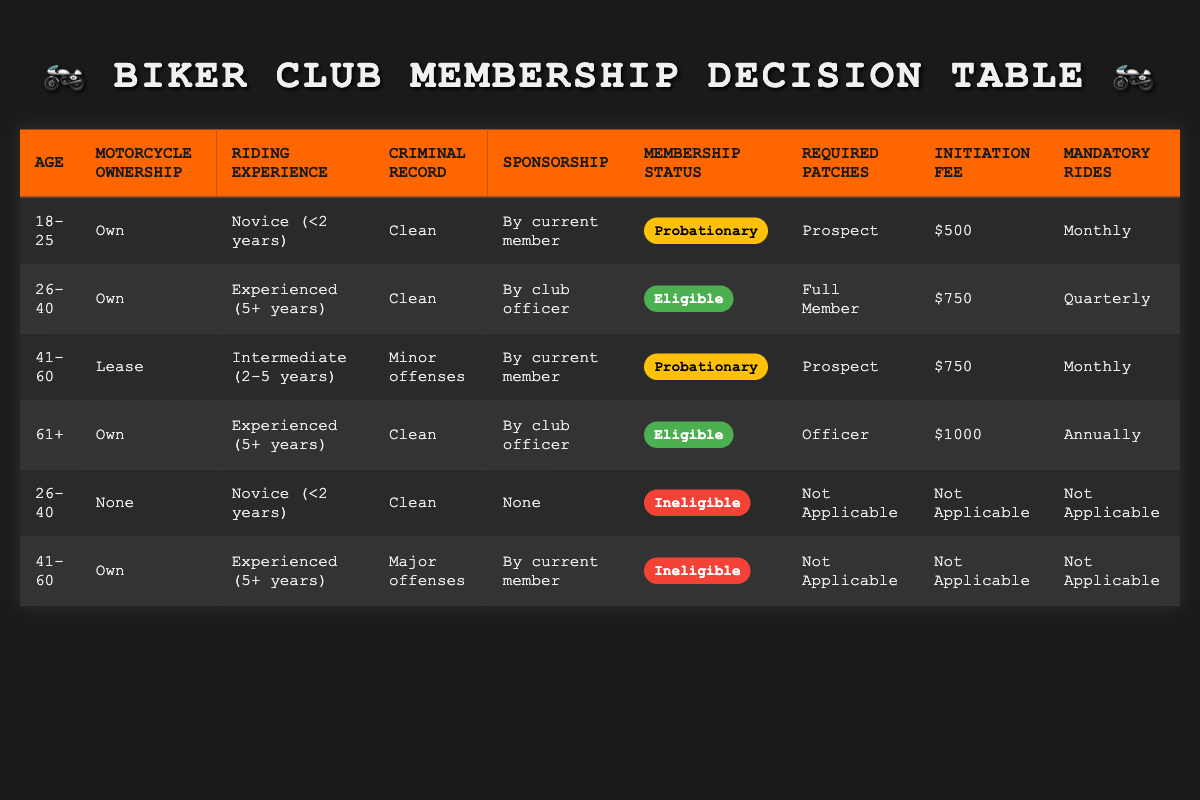What's the membership status for a 41-60 year old who leases a motorcycle and has intermediate riding experience with minor offenses? According to the table, this individual falls into the row for ages 41-60, leases their motorcycle, has intermediate riding experience, has a minor offense criminal record, and is sponsored by a current member, which corresponds to the "Probationary" membership status.
Answer: Probationary What is the initiation fee for a club member aged 18-25 who owns a motorcycle and is a novice with a clean record? From the table, the row that matches these criteria indicates that the initiation fee for this status is $500.
Answer: $500 Are members aged 61 and over who own a motorcycle and have experienced riding qualifications eligible for full membership? The table shows that these members are classified as "Eligible," but they actually receive the status of "Officer" instead of "Full Member," as it is specifically categorized. Therefore, they are not eligible for full membership.
Answer: No How many mandatory rides does a member aged 26-40 who owns a motorcycle and has 5+ years of riding experience need to complete? The table indicates that such a member has a quota of quarterly rides, as detailed in the corresponding row for this demographic and experience level.
Answer: Quarterly If a biker aged 41-60 has major offenses and owns a motorcycle, what is their membership eligibility? The table entry for a 41-60-year-old person with major offenses specifically denotes them as "Ineligible," regardless of motorcycle ownership, negating any chances of membership.
Answer: Ineligible What are the required patches for an eligible member aged 61+ with a clean record and who has been sponsored by a club officer? The table reveals that such an eligible member receives the "Officer" patch according to the specified conditions.
Answer: Officer Count the number of riders with a clean criminal record. Upon reviewing the table, members across different age categories and experience levels exhibit clean records in four rows, leading to a total count of four.
Answer: 4 Is it true that all eligible members must pay an initiation fee? The table shows that not all eligible members have an initiation fee; in the case categorized as "Ineligible," there is no fee indicated, making the statement false.
Answer: No Which age and ownership combination has the highest initiation fee, and what is that amount? Checking the table reveals that the age group 61+ with ownership of a motorcycle corresponds to the highest initiation fee of $1000, being the singular row that meets this criteria.
Answer: 61+, Own, $1000 